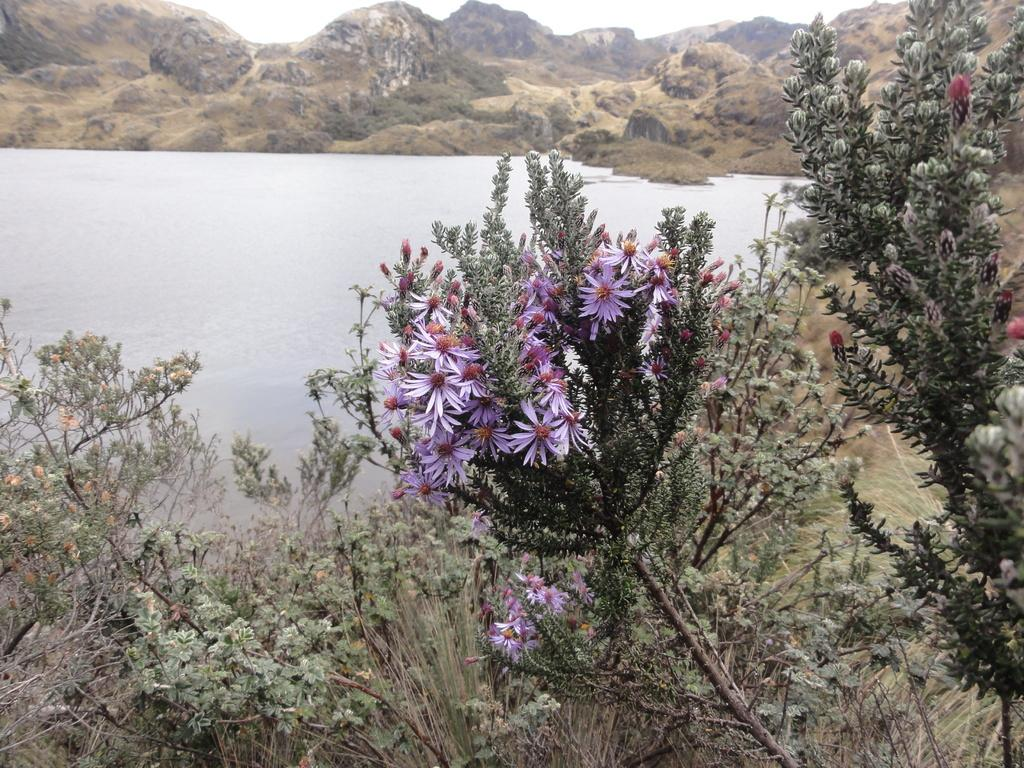What type of plants can be seen in the image? There are flowering plants in the image. What type of vegetation is present on the ground? There is grass in the image. What can be seen in the background of the image? There are mountains in the image. What is visible in the sky? The sky is visible in the image. Can you tell if the image was taken during the day or night? The image was likely taken during the day, as the sky is visible and there is no indication of darkness. Is there an oven visible in the image? No, there is no oven present in the image. Can you see any quicksand in the image? No, there is no quicksand present in the image. 